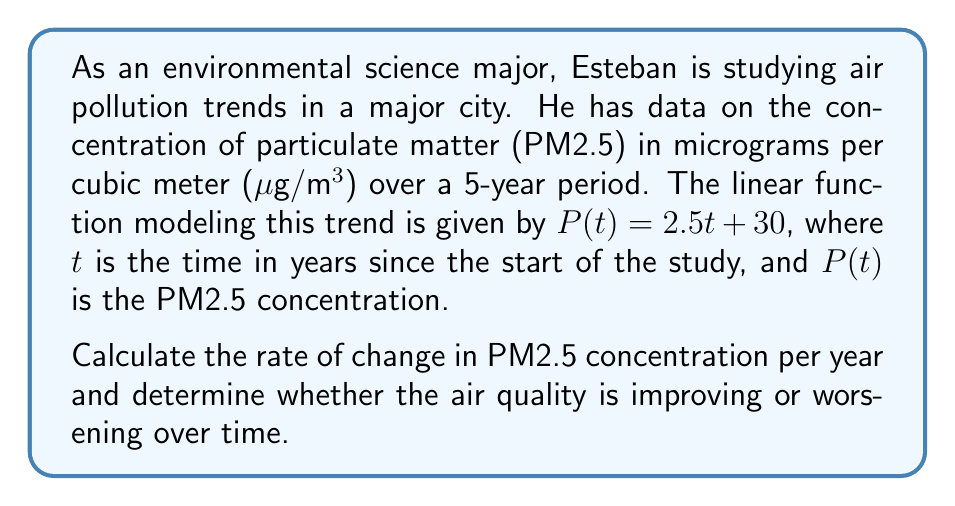Can you solve this math problem? To solve this problem, we need to analyze the given linear function:

$P(t) = 2.5t + 30$

In a linear function of the form $f(x) = mx + b$, the coefficient $m$ represents the slope of the line, which is equivalent to the rate of change.

In our function $P(t) = 2.5t + 30$:
- The coefficient of $t$ is 2.5
- This means the rate of change is 2.5 µg/m³ per year

To determine if the air quality is improving or worsening:
- A positive rate of change indicates an increase in PM2.5 concentration over time
- An increase in PM2.5 concentration means worsening air quality

Since the rate of change (2.5 µg/m³ per year) is positive, we can conclude that the air quality is worsening over time.
Answer: The rate of change in PM2.5 concentration is 2.5 µg/m³ per year, and the air quality is worsening over time. 